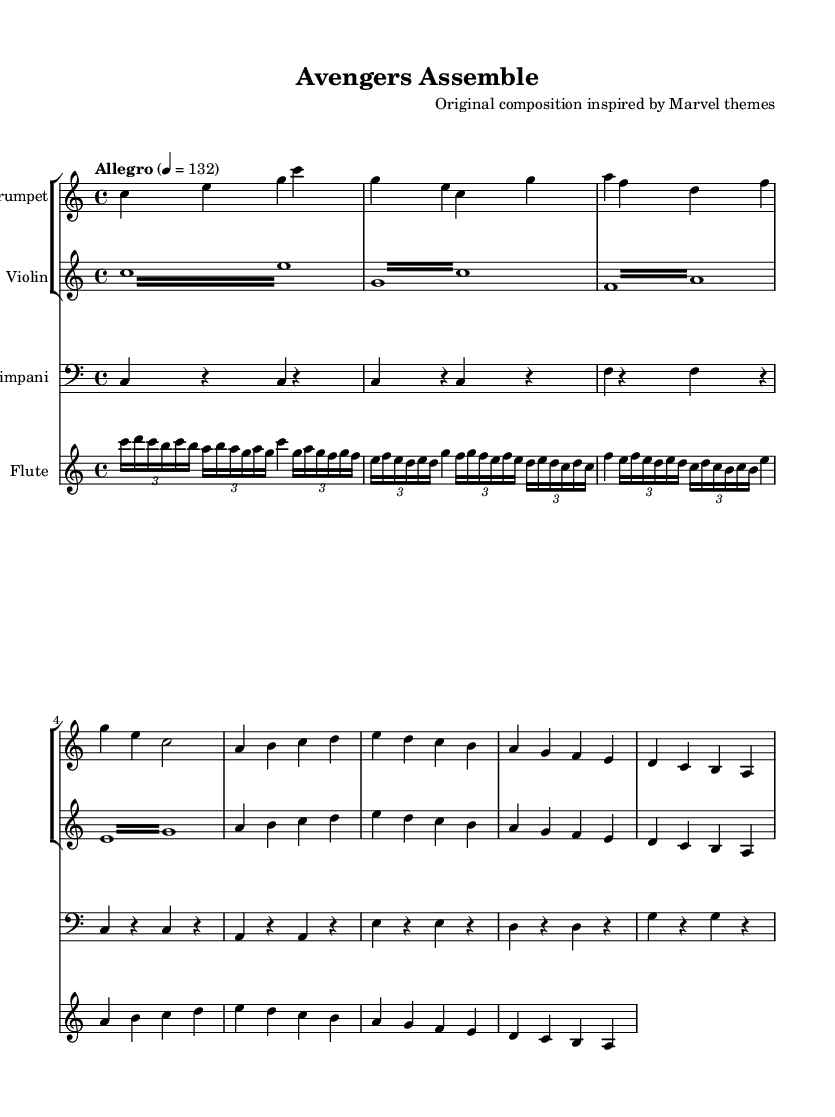What is the key signature of this music? The key signature is indicated right after the clef sign and shows that there are no sharps or flats, which defines the key of C major.
Answer: C major What is the time signature of this music? The time signature, placed at the beginning of the piece, shows "4/4," meaning there are four beats in each measure and the quarter note receives one beat.
Answer: 4/4 What is the tempo marking of this music? The tempo marking, found at the beginning of the score, specifies the speed of the piece as "Allegro" with a metronome marking of 132 beats per minute.
Answer: Allegro 132 Which instruments are included in this score? Analyzing the score structure, the instruments listed are Trumpet, Violin, Timpani, and Flute, each represented by its own staff.
Answer: Trumpet, Violin, Timpani, Flute What is the highest note played by the trumpet? By looking at the notes played by the trumpet, the highest note is labeled "g'." It appears at the end of the second measure in the first staff.
Answer: g' How many measures are in the violin part? Counting the measures in the violin part, there are eight separate groups of notes, each separated by vertical lines indicating measures.
Answer: Eight What type of musical piece is this represented sheet music for? The title in the header indicates this is an original composition inspired by Marvel themes, suggesting it is an epic orchestral score.
Answer: Epic orchestral score 